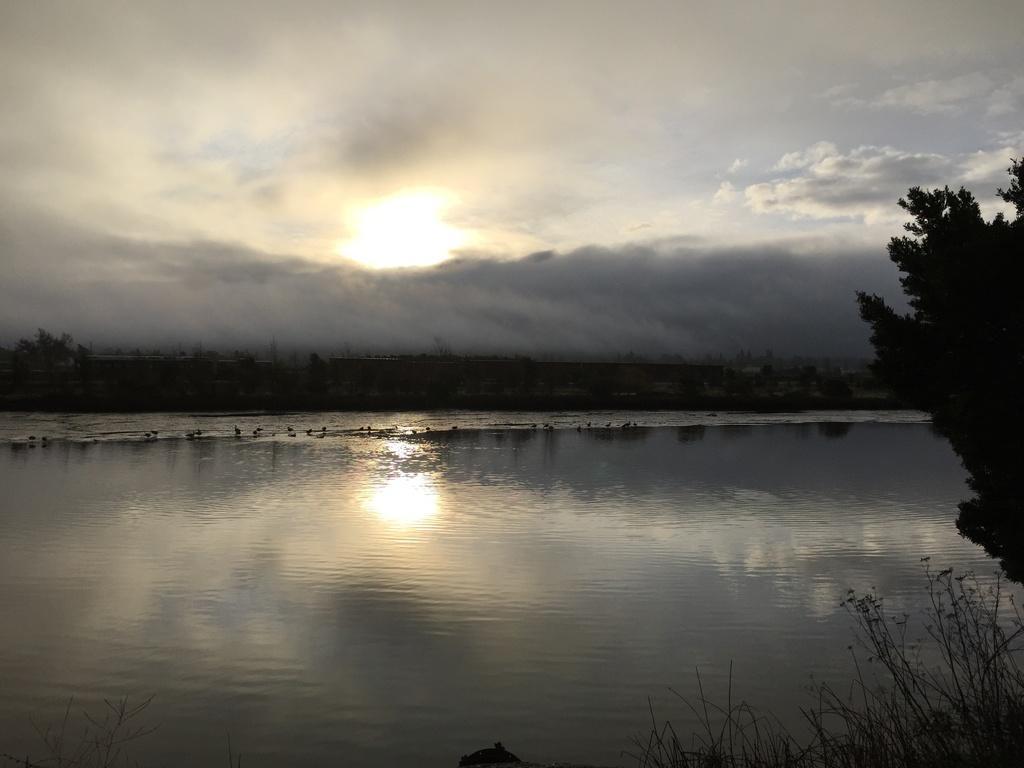Please provide a concise description of this image. In this image we can see a lake with water, a group of trees and sun in the sky with clouds. 